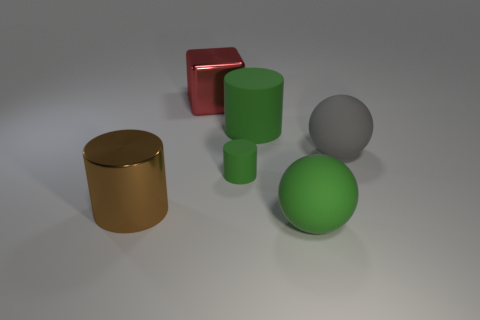There is a big cylinder that is on the left side of the red object; what is its material?
Give a very brief answer. Metal. Is there any other thing that has the same shape as the brown thing?
Make the answer very short. Yes. What number of metal things are either large brown objects or large red things?
Ensure brevity in your answer.  2. Are there fewer big matte cylinders left of the red shiny block than metallic things?
Provide a short and direct response. Yes. The metal object that is in front of the large green object behind the metal thing that is in front of the small thing is what shape?
Make the answer very short. Cylinder. Is the color of the big block the same as the tiny cylinder?
Provide a succinct answer. No. Is the number of green matte things greater than the number of gray objects?
Offer a terse response. Yes. What number of other objects are the same material as the large green cylinder?
Ensure brevity in your answer.  3. What number of objects are tiny matte cylinders or big shiny things that are to the right of the large brown object?
Make the answer very short. 2. Is the number of large metal blocks less than the number of cyan shiny cubes?
Your answer should be very brief. No. 